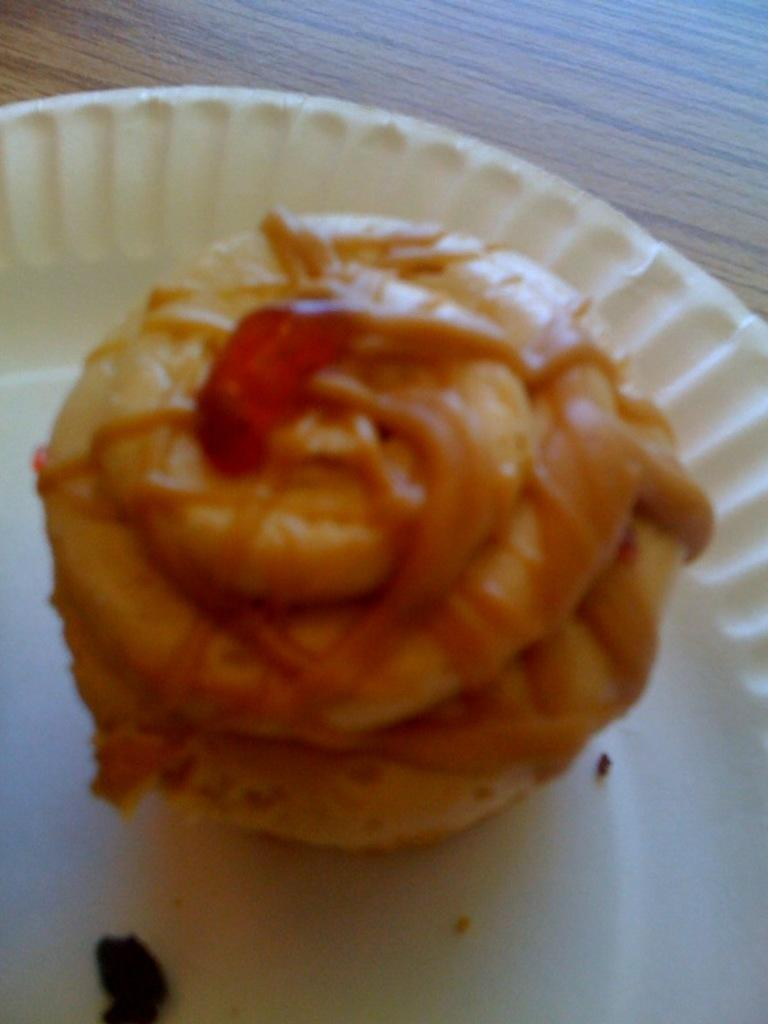What is the main subject of the image? There is a food item in the image. What is the color of the plate on which the food item is placed? The food item is on a white color plate. What type of surface is visible at the top of the image? There is a wooden surface at the top of the image. How many geese are playing music on the wooden surface in the image? There are no geese or musical instruments present in the image, so this scenario cannot be observed. 